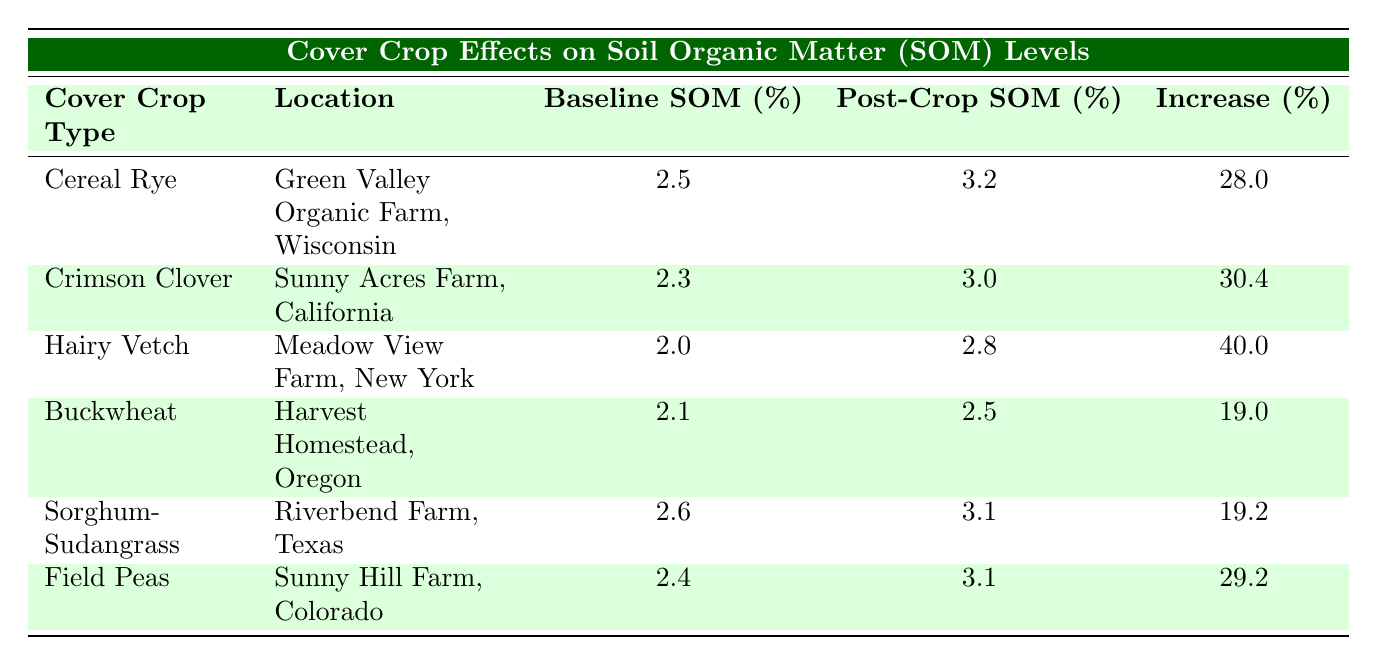What is the baseline SOM percentage for Hairy Vetch? The baseline SOM percentage for Hairy Vetch can be found in the corresponding row under the "Baseline SOM (%)" column, which indicates a value of 2.0.
Answer: 2.0 Which cover crop shows the highest increase percentage in SOM? To find the highest increase percentage, I look for the maximum value in the "Increase (%)" column. Hairy Vetch has an increase percentage of 40.0, which is the highest among all cover crops listed.
Answer: Hairy Vetch What is the average increase percentage across all cover crops? To calculate the average, I add all the increase percentages: (28.0 + 30.4 + 40.0 + 19.0 + 19.2 + 29.2) = 165.8. Then, I divide this sum by the number of cover crops, which is 6. So, 165.8 / 6 = 27.63.
Answer: 27.63 Did Buckwheat have a higher baseline SOM than Field Peas? The baseline SOM for Buckwheat is 2.1, while for Field Peas it is 2.4. Since 2.1 is less than 2.4, Buckwheat did not have a higher baseline SOM.
Answer: No What is the difference between the post-crop SOM of Cereal Rye and Sorghum-Sudangrass? The post-crop SOM for Cereal Rye is 3.2, and for Sorghum-Sudangrass, it is 3.1. I find the difference by subtracting: 3.2 - 3.1 = 0.1.
Answer: 0.1 Is there any cover crop that has a baseline SOM of 2.4? By checking the table, I can see that the baseline SOM for Field Peas is 2.4, so the statement is true.
Answer: Yes Which cover crop types increased SOM by less than 20%? I check the "Increase (%)" column for values less than 20. The values are 19.0 for Buckwheat and 19.2 for Sorghum-Sudangrass. Thus, those two cover crops increased SOM by less than 20%.
Answer: Buckwheat, Sorghum-Sudangrass Which location showed the lowest baseline SOM percentage? Looking at the "Baseline SOM (%)" column, Hairy Vetch has the lowest value at 2.0.
Answer: Meadow View Farm, New York Calculate the total increase in SOM for all cover crops combined. I sum the increase percentages: 28.0 + 30.4 + 40.0 + 19.0 + 19.2 + 29.2 = 165.8. Therefore, the total increase in SOM for all cover crops is 165.8.
Answer: 165.8 